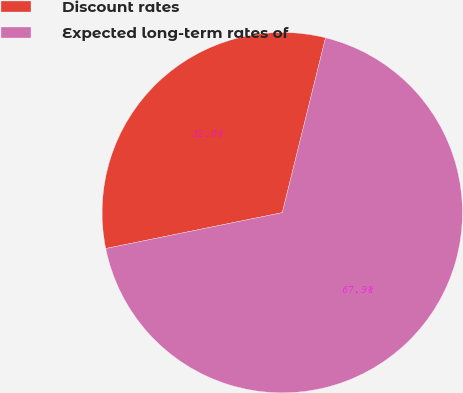Convert chart to OTSL. <chart><loc_0><loc_0><loc_500><loc_500><pie_chart><fcel>Discount rates<fcel>Expected long-term rates of<nl><fcel>32.05%<fcel>67.95%<nl></chart> 